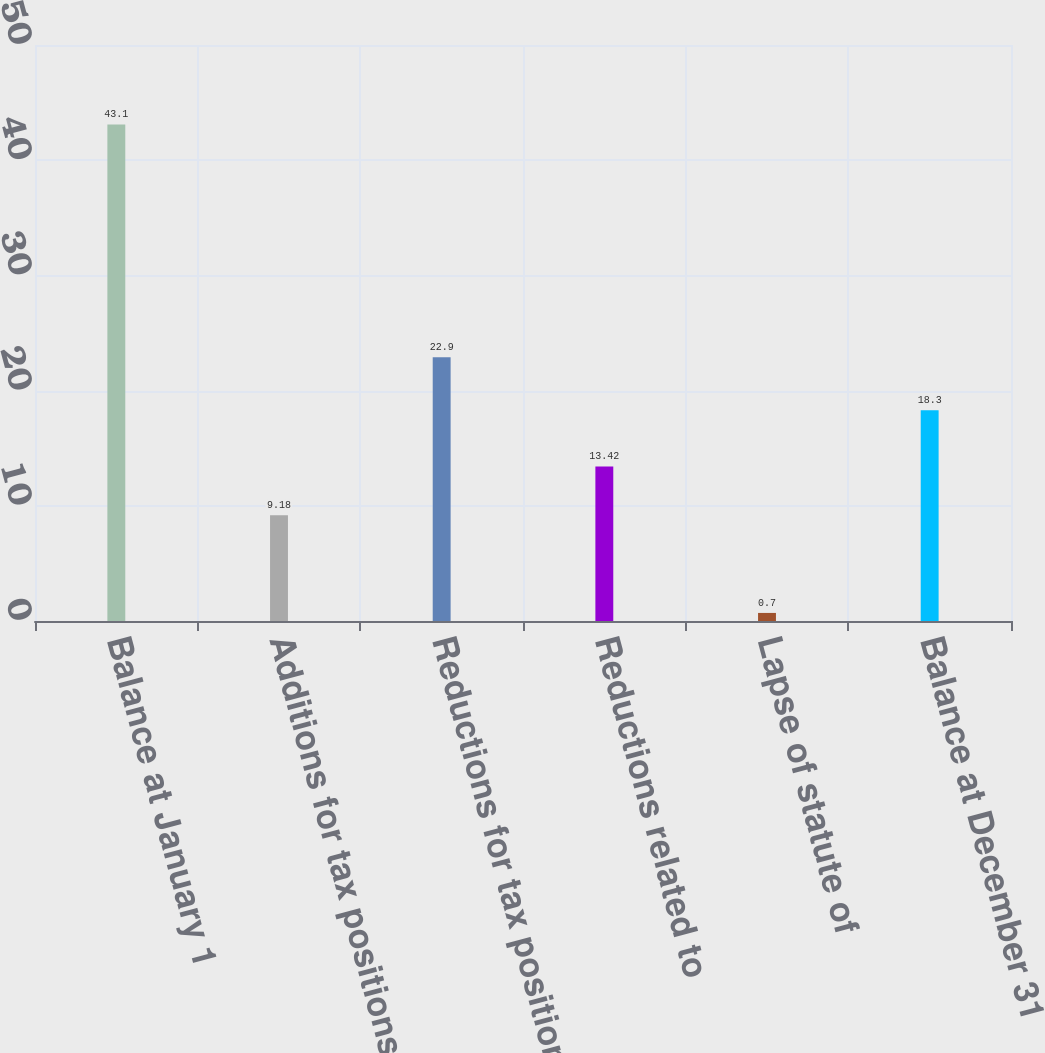Convert chart to OTSL. <chart><loc_0><loc_0><loc_500><loc_500><bar_chart><fcel>Balance at January 1<fcel>Additions for tax positions<fcel>Reductions for tax positions<fcel>Reductions related to<fcel>Lapse of statute of<fcel>Balance at December 31<nl><fcel>43.1<fcel>9.18<fcel>22.9<fcel>13.42<fcel>0.7<fcel>18.3<nl></chart> 